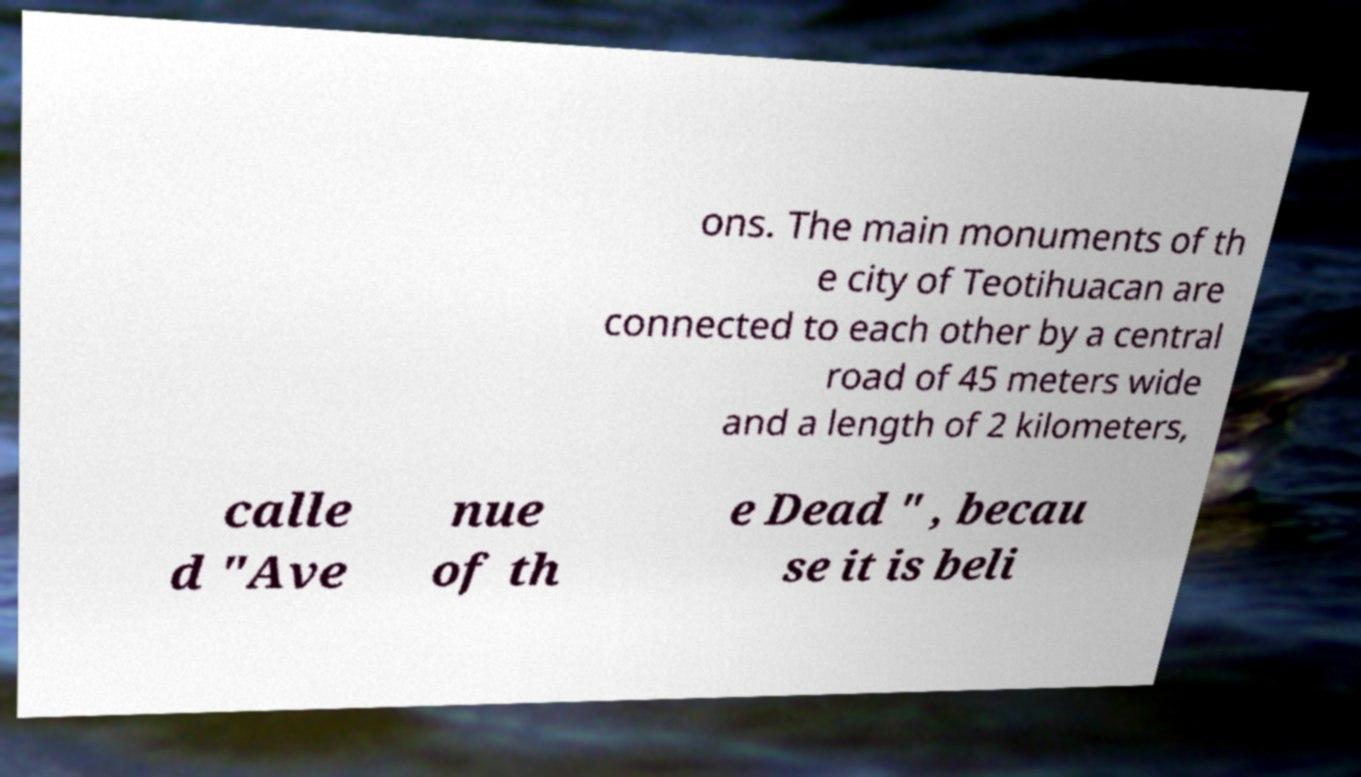Could you assist in decoding the text presented in this image and type it out clearly? ons. The main monuments of th e city of Teotihuacan are connected to each other by a central road of 45 meters wide and a length of 2 kilometers, calle d "Ave nue of th e Dead " , becau se it is beli 